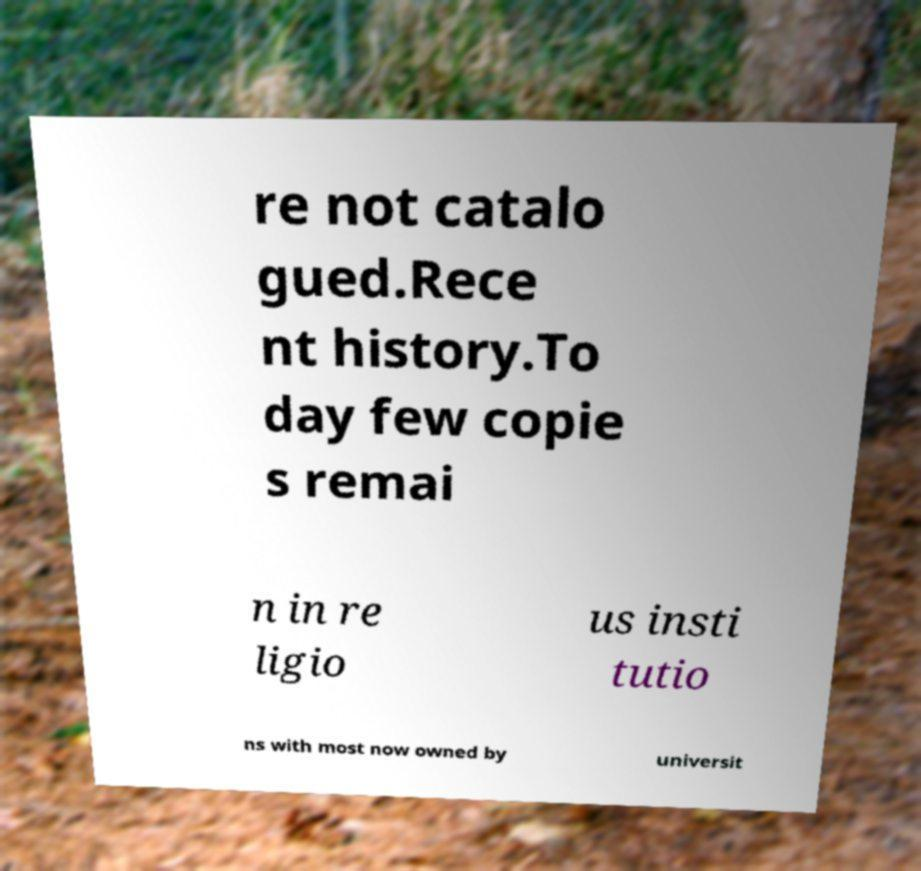For documentation purposes, I need the text within this image transcribed. Could you provide that? re not catalo gued.Rece nt history.To day few copie s remai n in re ligio us insti tutio ns with most now owned by universit 